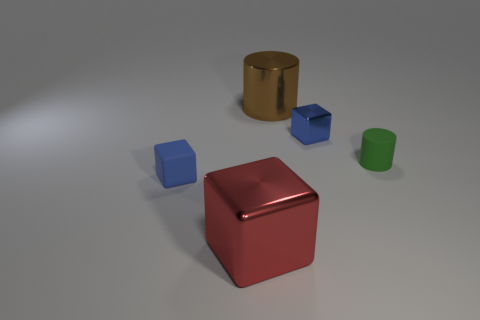Are there any large brown shiny objects that have the same shape as the large red metal thing? no 